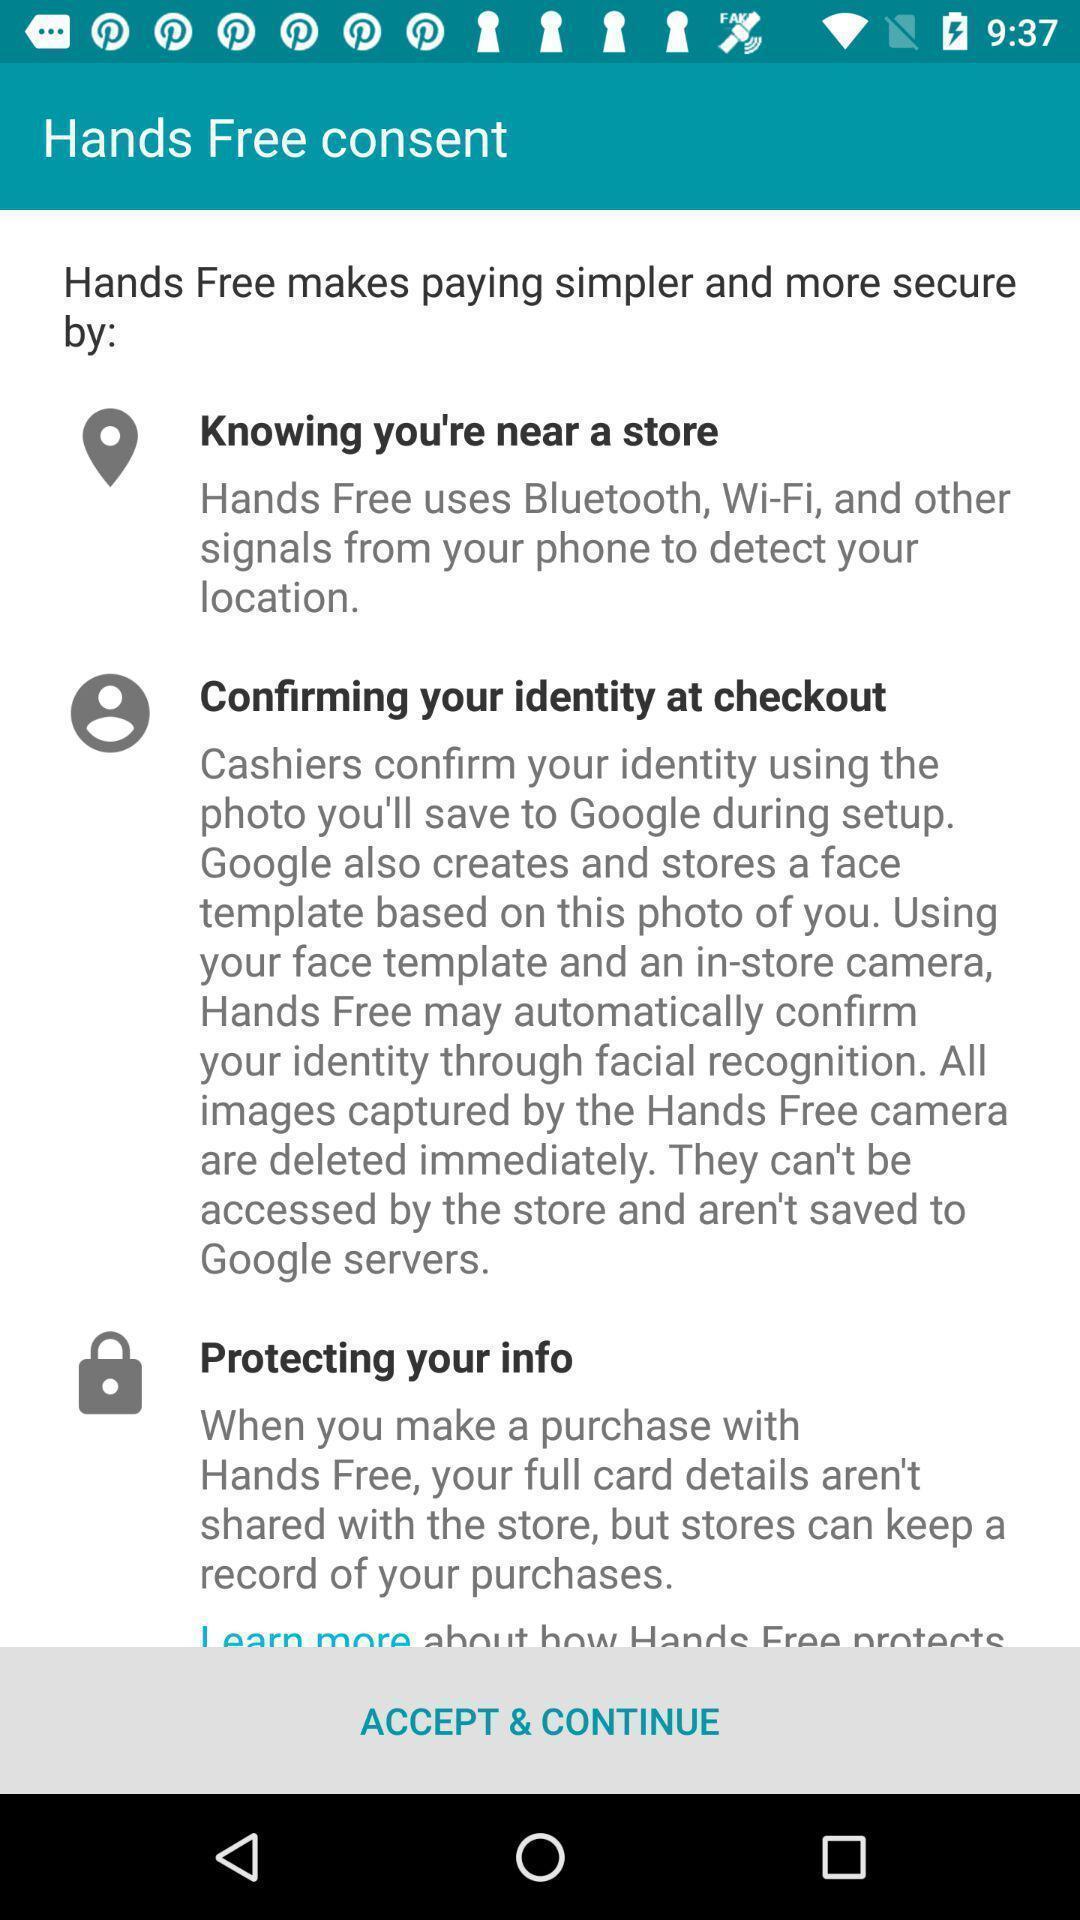Tell me about the visual elements in this screen capture. Page to accept an continue in the payment app. 